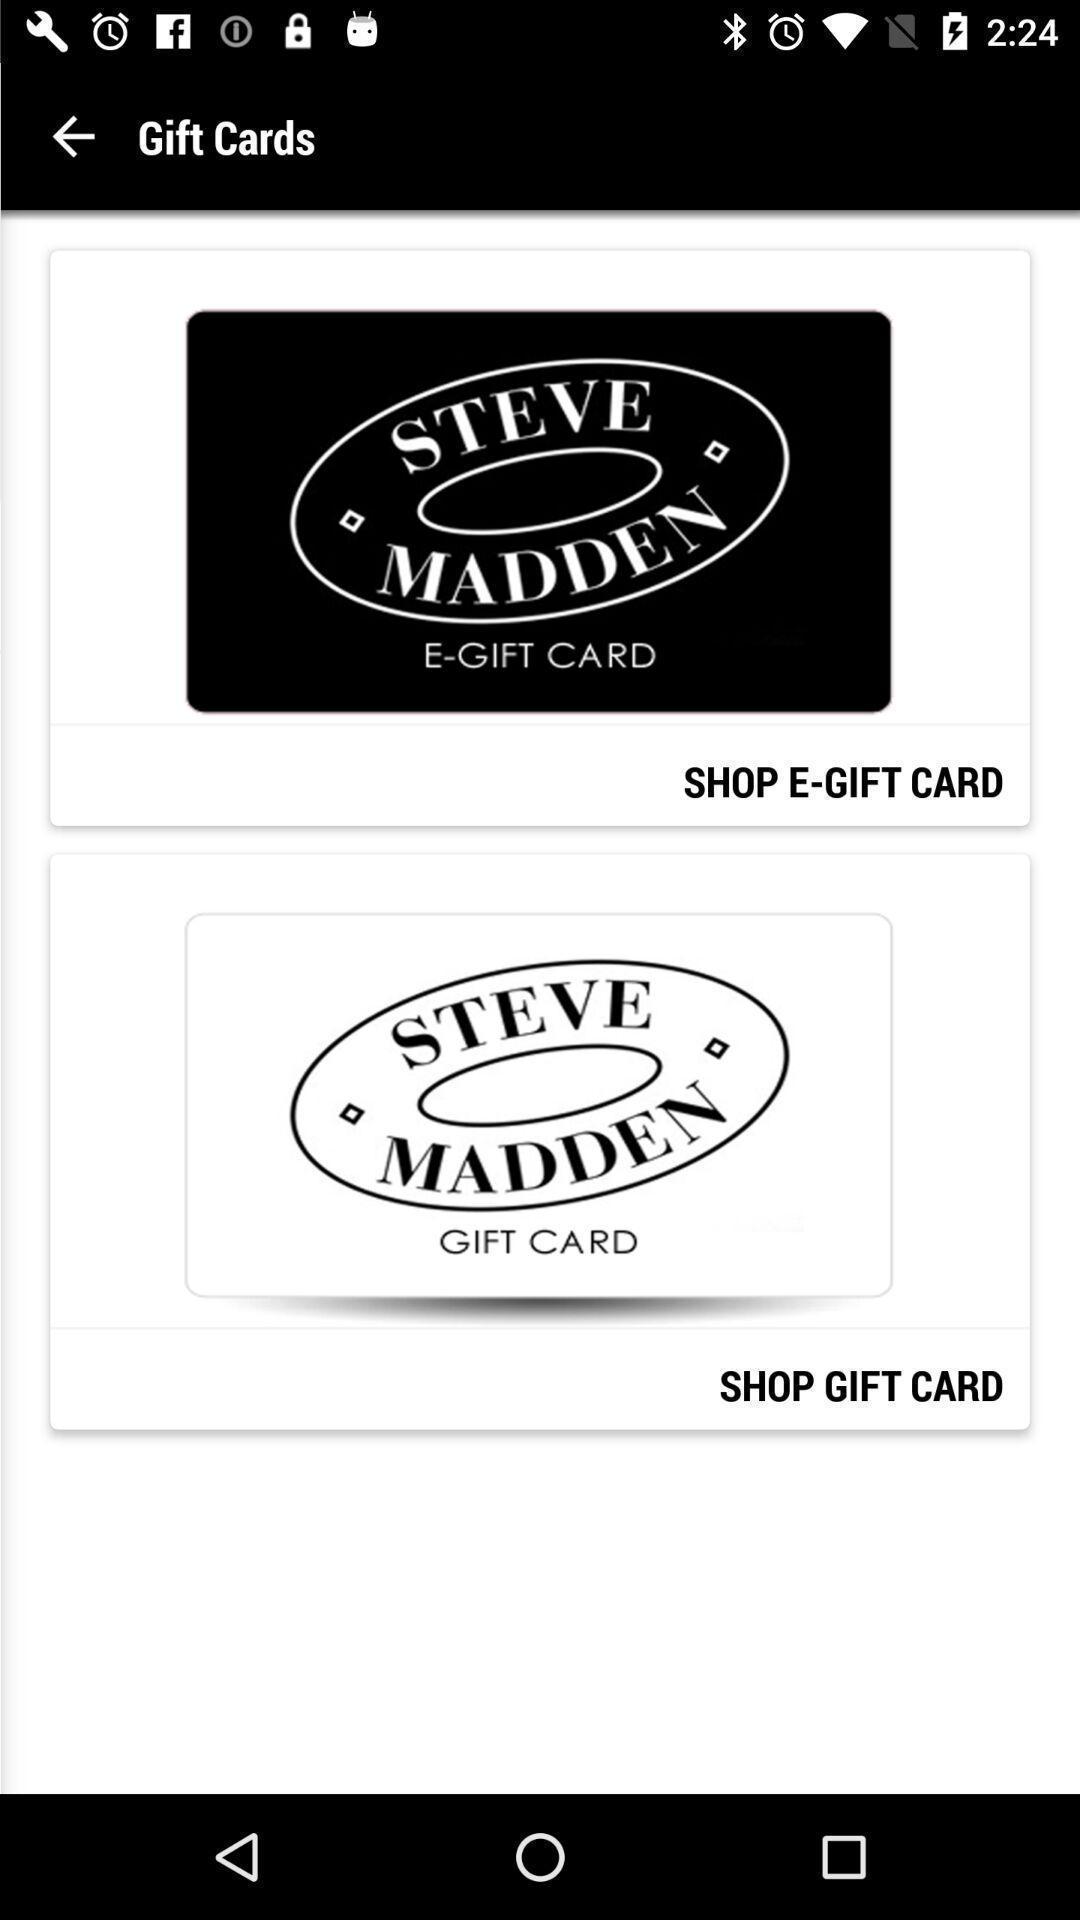Give me a narrative description of this picture. Two gift cards are available. 